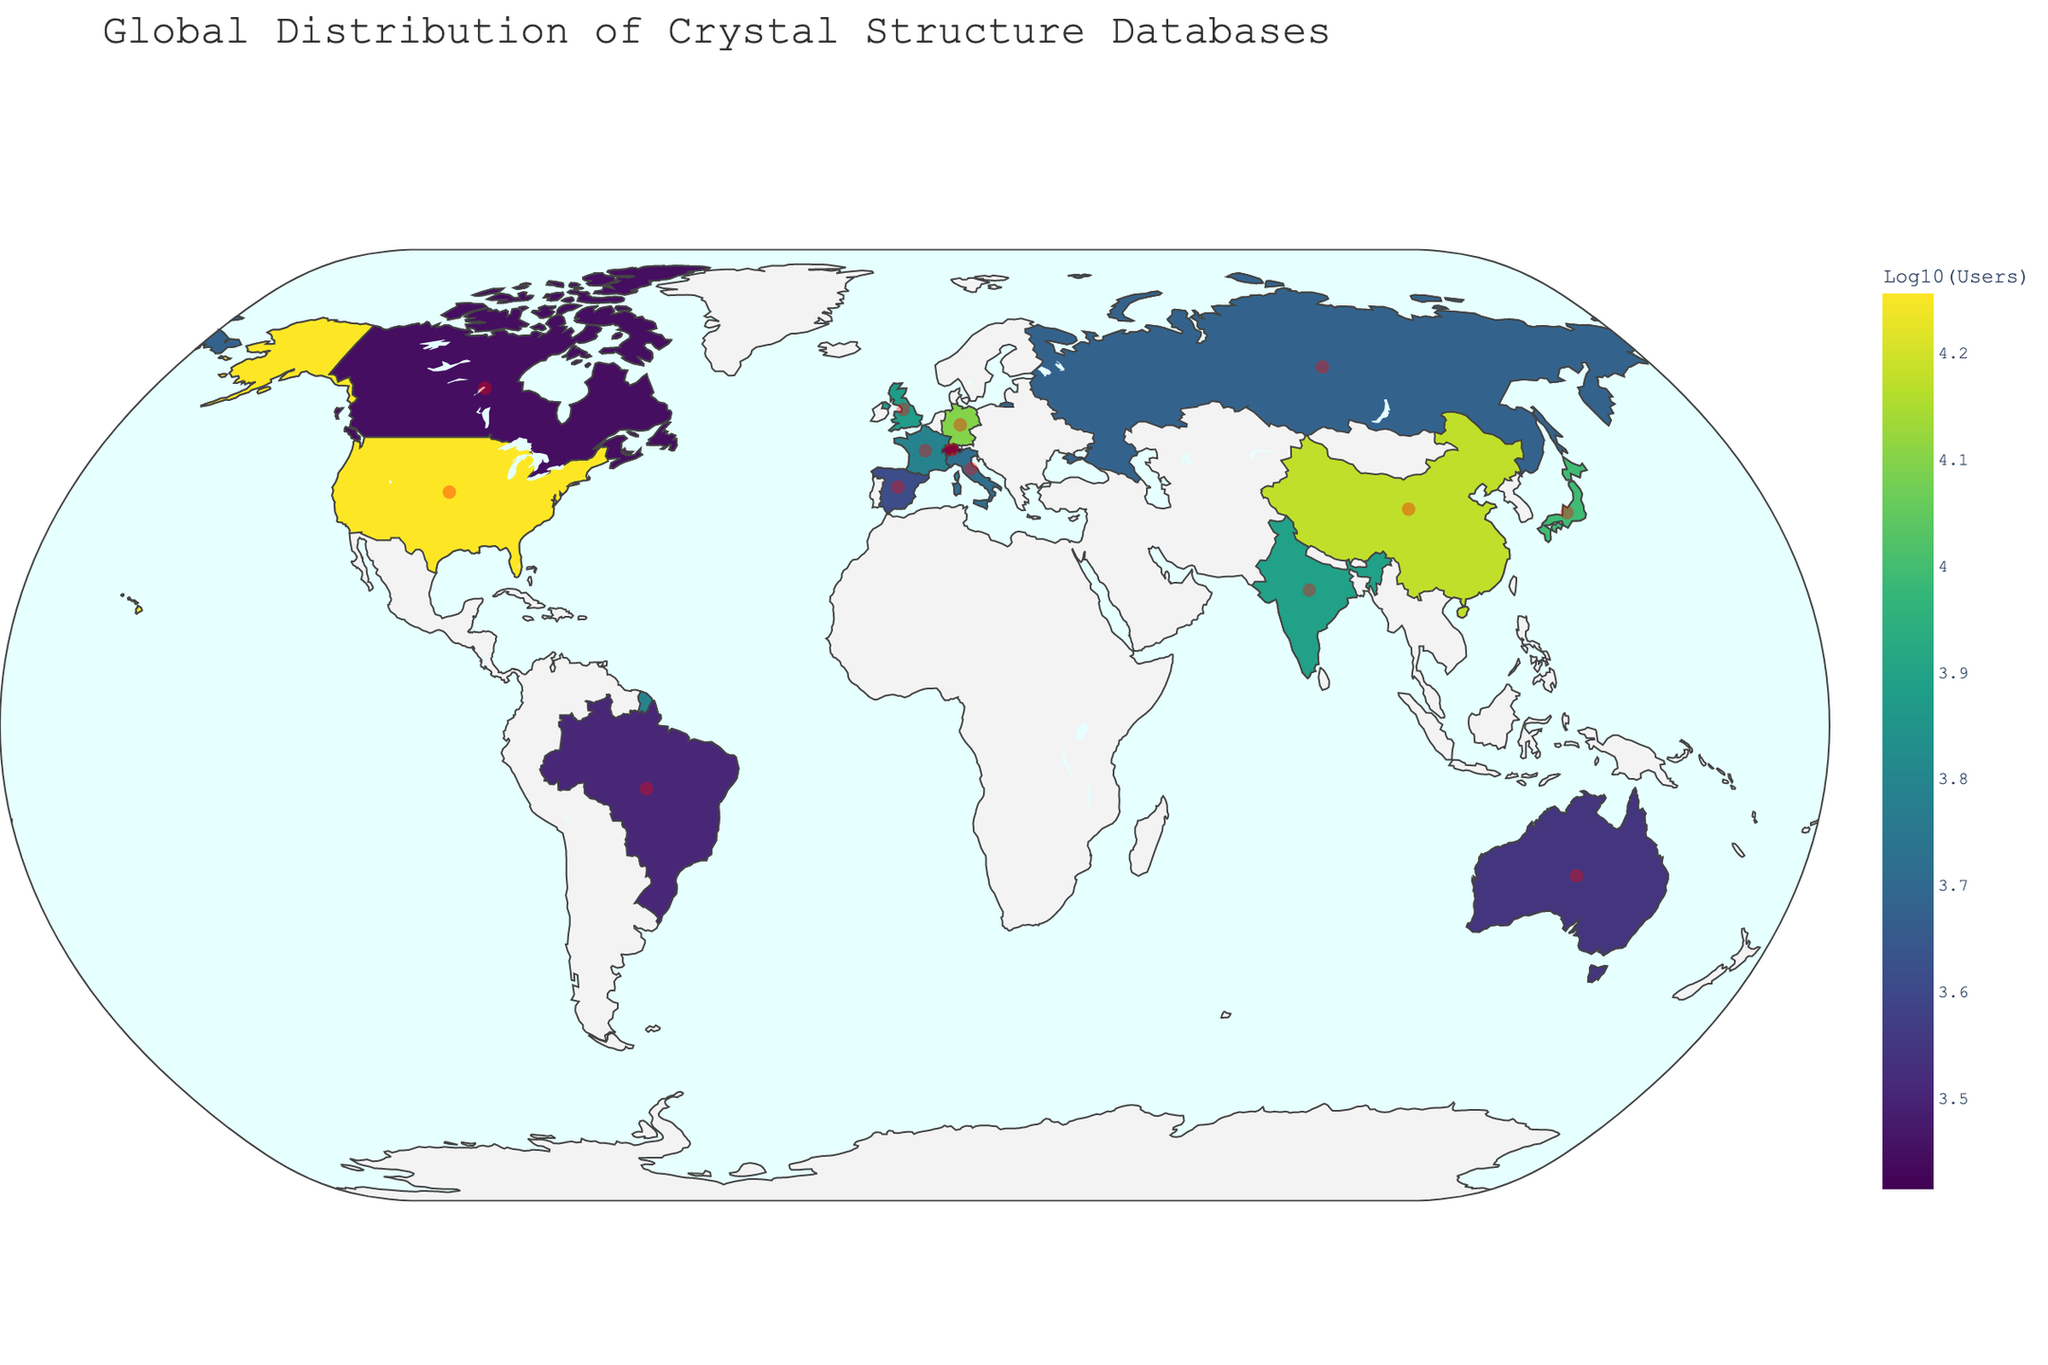What is the title of the figure? The title is often displayed at the top of a figure. Looking at the top, the title is visible.
Answer: Global Distribution of Crystal Structure Databases What is the color scale used for the number of users? By examining the color coding of the map, we can see that the color transitions smoothly from one end to the other. This indicates a continuous color scale.
Answer: Viridis Which country has the highest number of publications? By looking at the size of scatter markers (red circles) and the hover text, find the largest one.
Answer: United States How many users are there in China? Hover over China on the map and read the hover data that shows the number of users.
Answer: 15000 How does the number of users in Germany compare to that in Japan? Find the hover texts for Germany and Japan, note the number of users, and compare them.
Answer: Germany has 2700 more users than Japan What is the average number of publications among the countries mentioned? Sum the number of publications for all countries and divide by the number of countries (14).
Answer: 2000 Is there any correlation between the number of users and the number of publications? Compare the size of the markers (publications) with the color intensity (users). A general trend where more users correspond to more publications would indicate a positive correlation.
Answer: Yes, there is a positive correlation Which countries use the Cambridge Structural Database? Hover over countries and check which one mentions "Cambridge Structural Database" in the hover information.
Answer: Germany Which country has the fewest users and what is the value? Find the country with the lightest color on the map and hover to see the exact number of users.
Answer: Switzerland with 2600 users List the databases used in the United States and China. Hover over the United States and China and read the database names from the hover information.
Answer: Inorganic Crystal Structure Database, Materials Project 